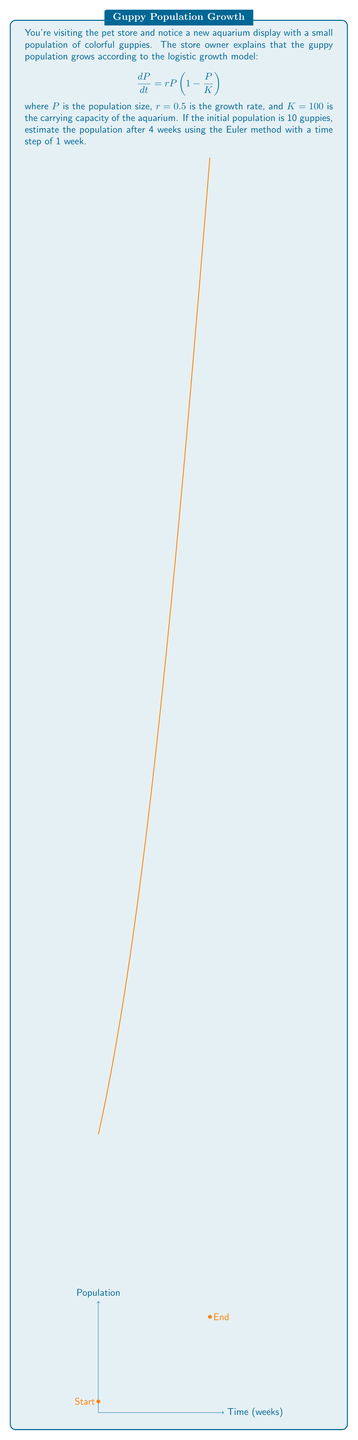Solve this math problem. To solve this problem using the Euler method, we'll follow these steps:

1) The Euler method is given by the formula:
   $$P_{n+1} = P_n + h \cdot f(t_n, P_n)$$
   where $h$ is the time step, and $f(t, P) = rP(1 - \frac{P}{K})$

2) Given:
   - Initial population $P_0 = 10$
   - Growth rate $r = 0.5$
   - Carrying capacity $K = 100$
   - Time step $h = 1$ week
   - We need to calculate for 4 weeks

3) Let's calculate step by step:

   Week 0: $P_0 = 10$

   Week 1: $P_1 = P_0 + h \cdot r P_0 (1 - \frac{P_0}{K})$
           $= 10 + 1 \cdot 0.5 \cdot 10 (1 - \frac{10}{100}) = 14.5$

   Week 2: $P_2 = P_1 + h \cdot r P_1 (1 - \frac{P_1}{K})$
           $= 14.5 + 1 \cdot 0.5 \cdot 14.5 (1 - \frac{14.5}{100}) = 20.1125$

   Week 3: $P_3 = P_2 + h \cdot r P_2 (1 - \frac{P_2}{K})$
           $= 20.1125 + 1 \cdot 0.5 \cdot 20.1125 (1 - \frac{20.1125}{100}) = 26.6471$

   Week 4: $P_4 = P_3 + h \cdot r P_3 (1 - \frac{P_3}{K})$
           $= 26.6471 + 1 \cdot 0.5 \cdot 26.6471 (1 - \frac{26.6471}{100}) = 33.7595$

4) Therefore, the estimated guppy population after 4 weeks is approximately 33.7595, which we can round to 34 guppies.
Answer: 34 guppies 